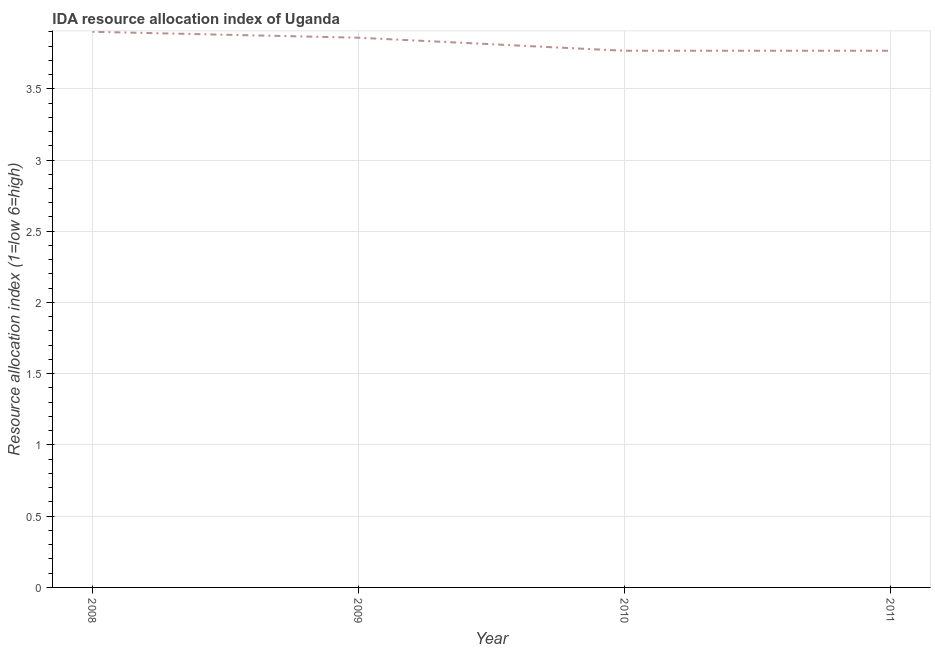What is the ida resource allocation index in 2011?
Keep it short and to the point. 3.77. Across all years, what is the maximum ida resource allocation index?
Offer a terse response. 3.9. Across all years, what is the minimum ida resource allocation index?
Offer a very short reply. 3.77. In which year was the ida resource allocation index minimum?
Offer a terse response. 2010. What is the sum of the ida resource allocation index?
Your answer should be very brief. 15.29. What is the average ida resource allocation index per year?
Make the answer very short. 3.82. What is the median ida resource allocation index?
Offer a terse response. 3.81. Is the difference between the ida resource allocation index in 2009 and 2010 greater than the difference between any two years?
Make the answer very short. No. What is the difference between the highest and the second highest ida resource allocation index?
Keep it short and to the point. 0.04. What is the difference between the highest and the lowest ida resource allocation index?
Offer a terse response. 0.13. How many lines are there?
Your answer should be very brief. 1. What is the difference between two consecutive major ticks on the Y-axis?
Provide a short and direct response. 0.5. Does the graph contain grids?
Give a very brief answer. Yes. What is the title of the graph?
Keep it short and to the point. IDA resource allocation index of Uganda. What is the label or title of the Y-axis?
Offer a very short reply. Resource allocation index (1=low 6=high). What is the Resource allocation index (1=low 6=high) in 2008?
Make the answer very short. 3.9. What is the Resource allocation index (1=low 6=high) of 2009?
Your answer should be compact. 3.86. What is the Resource allocation index (1=low 6=high) of 2010?
Provide a short and direct response. 3.77. What is the Resource allocation index (1=low 6=high) of 2011?
Offer a very short reply. 3.77. What is the difference between the Resource allocation index (1=low 6=high) in 2008 and 2009?
Ensure brevity in your answer.  0.04. What is the difference between the Resource allocation index (1=low 6=high) in 2008 and 2010?
Ensure brevity in your answer.  0.13. What is the difference between the Resource allocation index (1=low 6=high) in 2008 and 2011?
Your response must be concise. 0.13. What is the difference between the Resource allocation index (1=low 6=high) in 2009 and 2010?
Your answer should be very brief. 0.09. What is the difference between the Resource allocation index (1=low 6=high) in 2009 and 2011?
Give a very brief answer. 0.09. What is the ratio of the Resource allocation index (1=low 6=high) in 2008 to that in 2010?
Provide a succinct answer. 1.03. What is the ratio of the Resource allocation index (1=low 6=high) in 2008 to that in 2011?
Your response must be concise. 1.03. What is the ratio of the Resource allocation index (1=low 6=high) in 2009 to that in 2010?
Your answer should be compact. 1.02. What is the ratio of the Resource allocation index (1=low 6=high) in 2009 to that in 2011?
Provide a succinct answer. 1.02. What is the ratio of the Resource allocation index (1=low 6=high) in 2010 to that in 2011?
Keep it short and to the point. 1. 